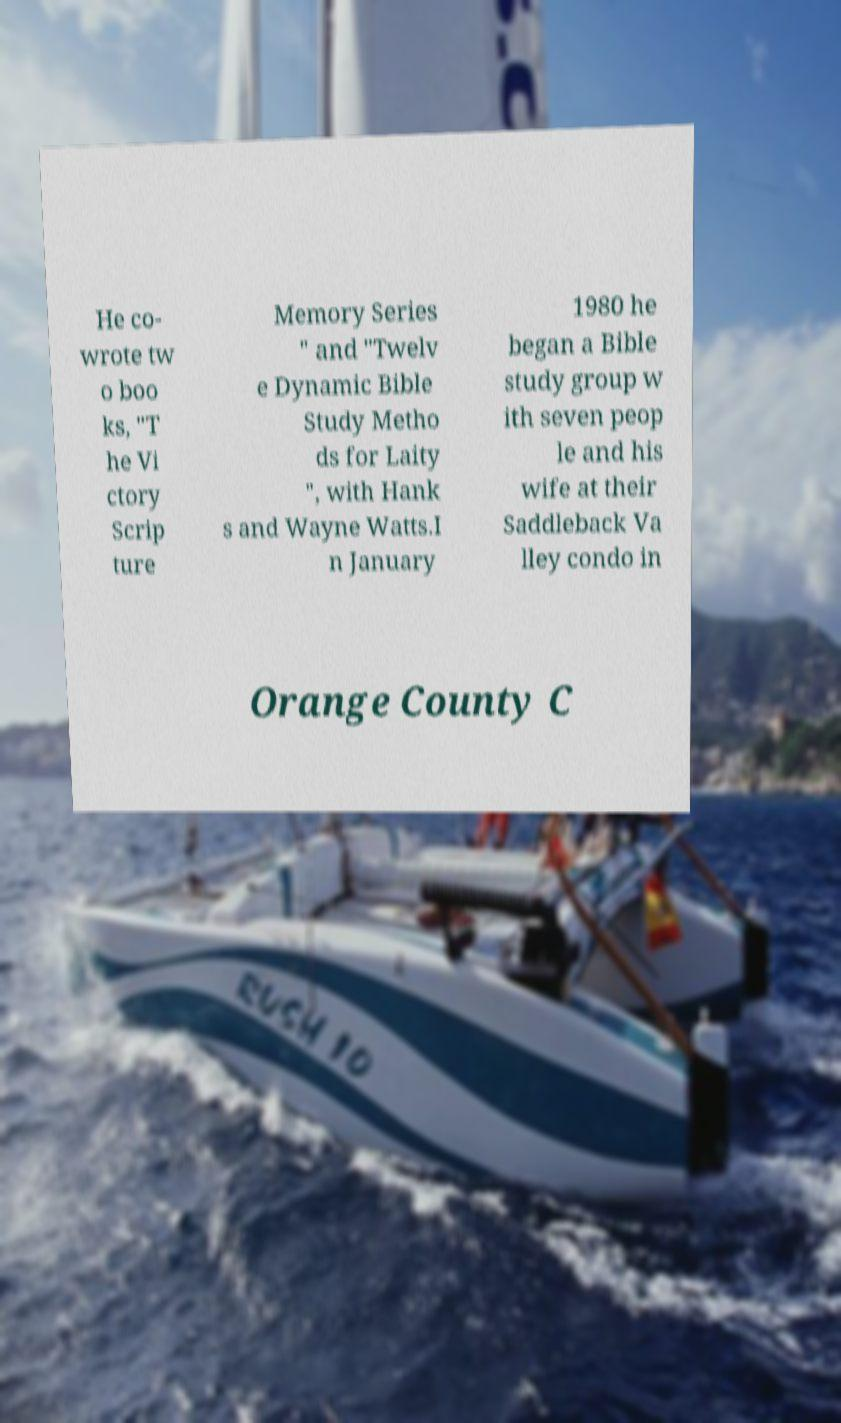Please read and relay the text visible in this image. What does it say? He co- wrote tw o boo ks, "T he Vi ctory Scrip ture Memory Series " and "Twelv e Dynamic Bible Study Metho ds for Laity ", with Hank s and Wayne Watts.I n January 1980 he began a Bible study group w ith seven peop le and his wife at their Saddleback Va lley condo in Orange County C 